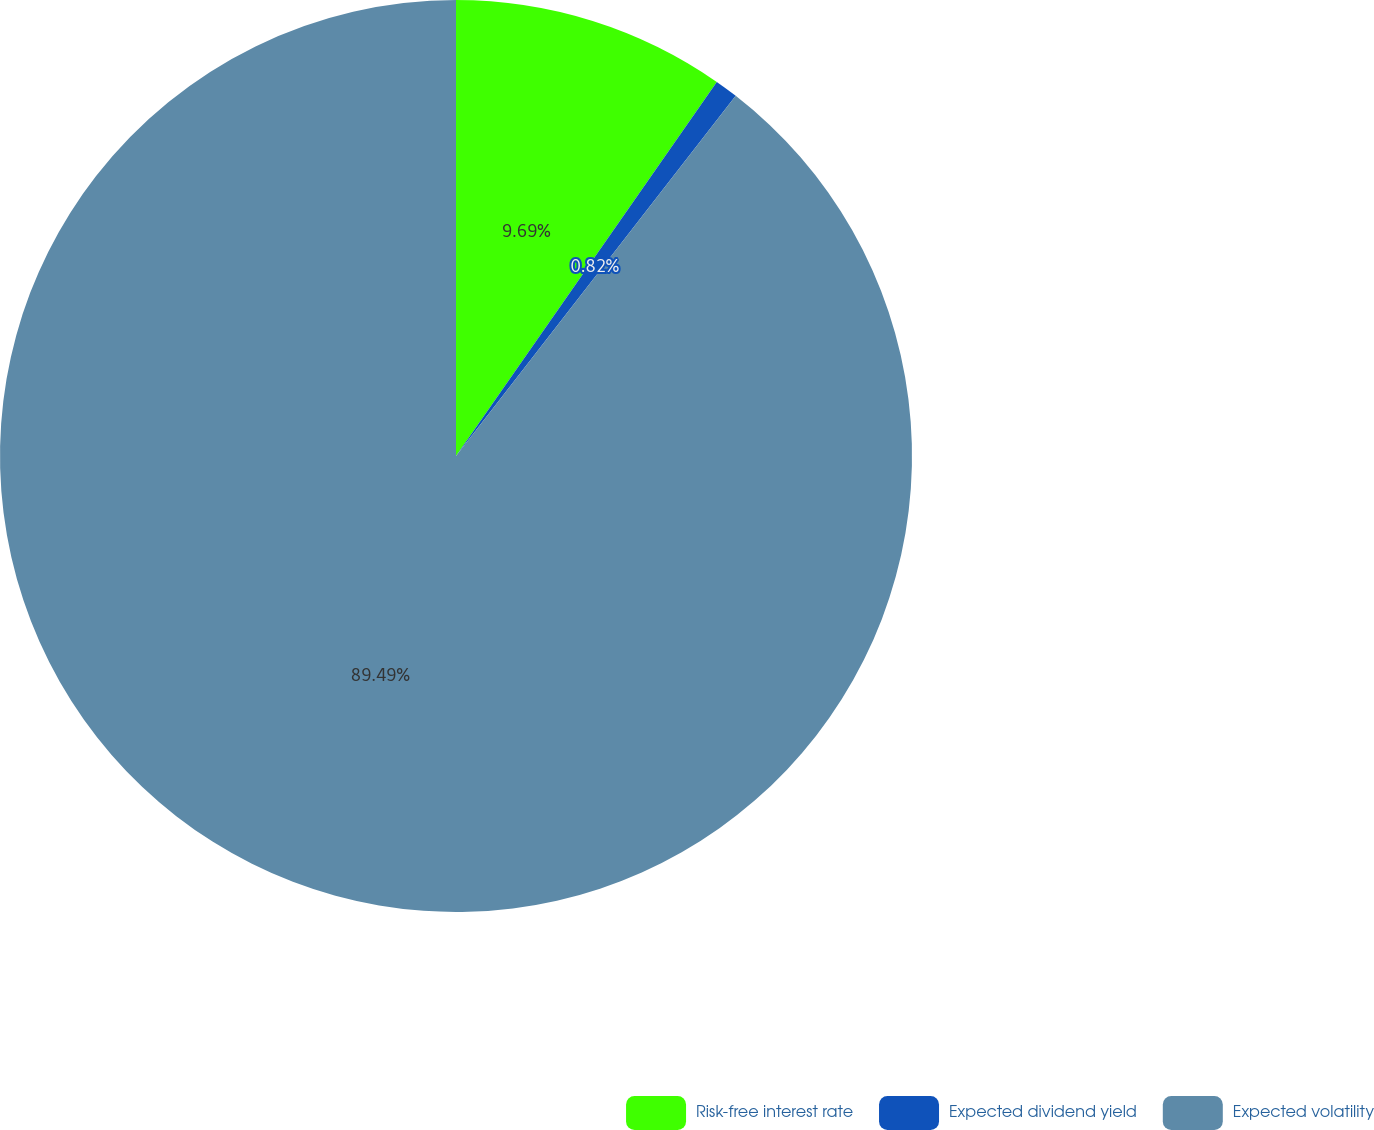<chart> <loc_0><loc_0><loc_500><loc_500><pie_chart><fcel>Risk-free interest rate<fcel>Expected dividend yield<fcel>Expected volatility<nl><fcel>9.69%<fcel>0.82%<fcel>89.49%<nl></chart> 